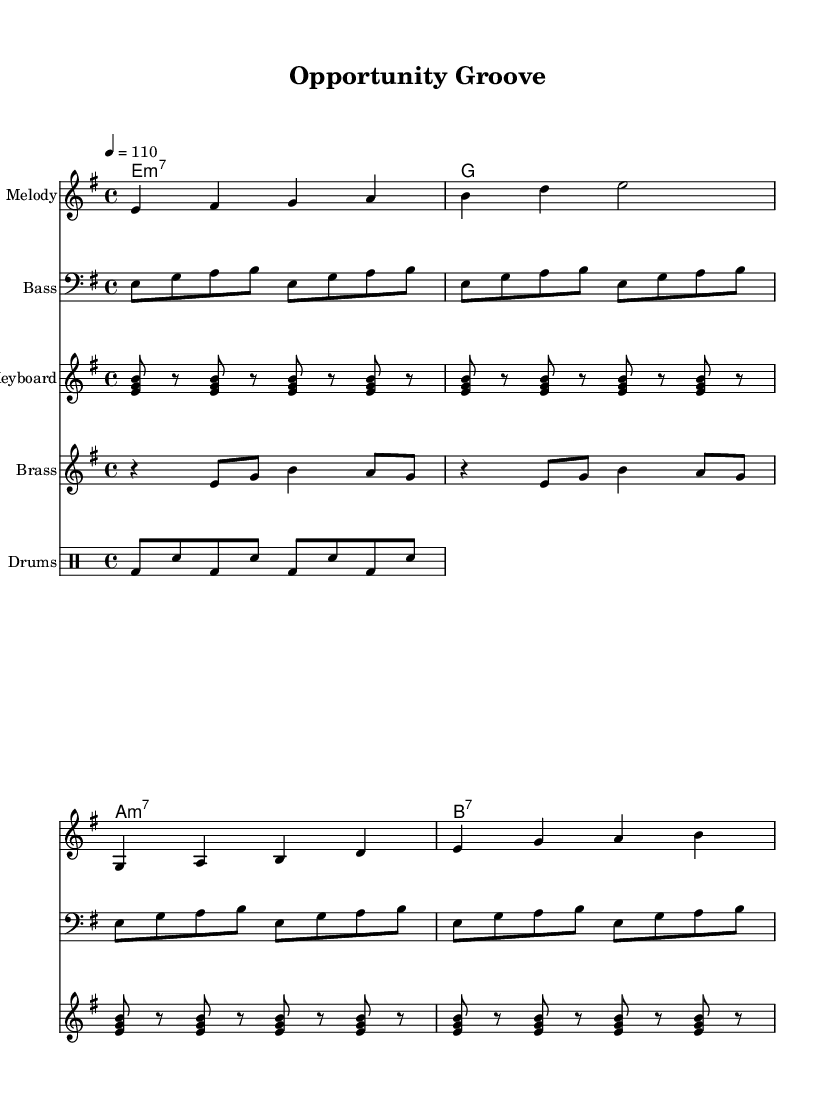What is the key signature of this music? The key signature is E minor, which contains one sharp (F#). You can determine this by looking at the key signature shown at the beginning of the staff.
Answer: E minor What is the time signature of this music? The time signature is 4/4, which means there are four beats in each measure and a quarter note gets one beat. This is indicated by the "4/4" notation seen at the beginning of the score.
Answer: 4/4 What is the tempo marking for this piece? The tempo marking is 110 beats per minute, indicated by "4 = 110" in the header section. This tells performers how fast to play the piece.
Answer: 110 How many measures are in the verse? The verse contains 4 measures. By counting the measures in the melody notation and aligning it with the lyrics, you can see that there are four distinct measures for the verse.
Answer: 4 What is the first chord played on the guitar? The first chord played on the guitar is E minor seven (Em7). You can identify this by looking at the chord indication in the chord mode section.
Answer: E minor seven What rhythmic pattern is primarily used in the drums? The rhythmic pattern used in the drums consists of bass drum and snare hits alternately, creating a consistent groove typical to funk music. This can be seen in the drum notation.
Answer: Bass and snare What do the lyrics of the chorus focus on? The lyrics of the chorus emphasize the need for equality and opportunity, as seen in the words which state "We need opportunity, equality for you and me." This highlights the overarching theme of the song addressing economic inequality.
Answer: Equality and opportunity 